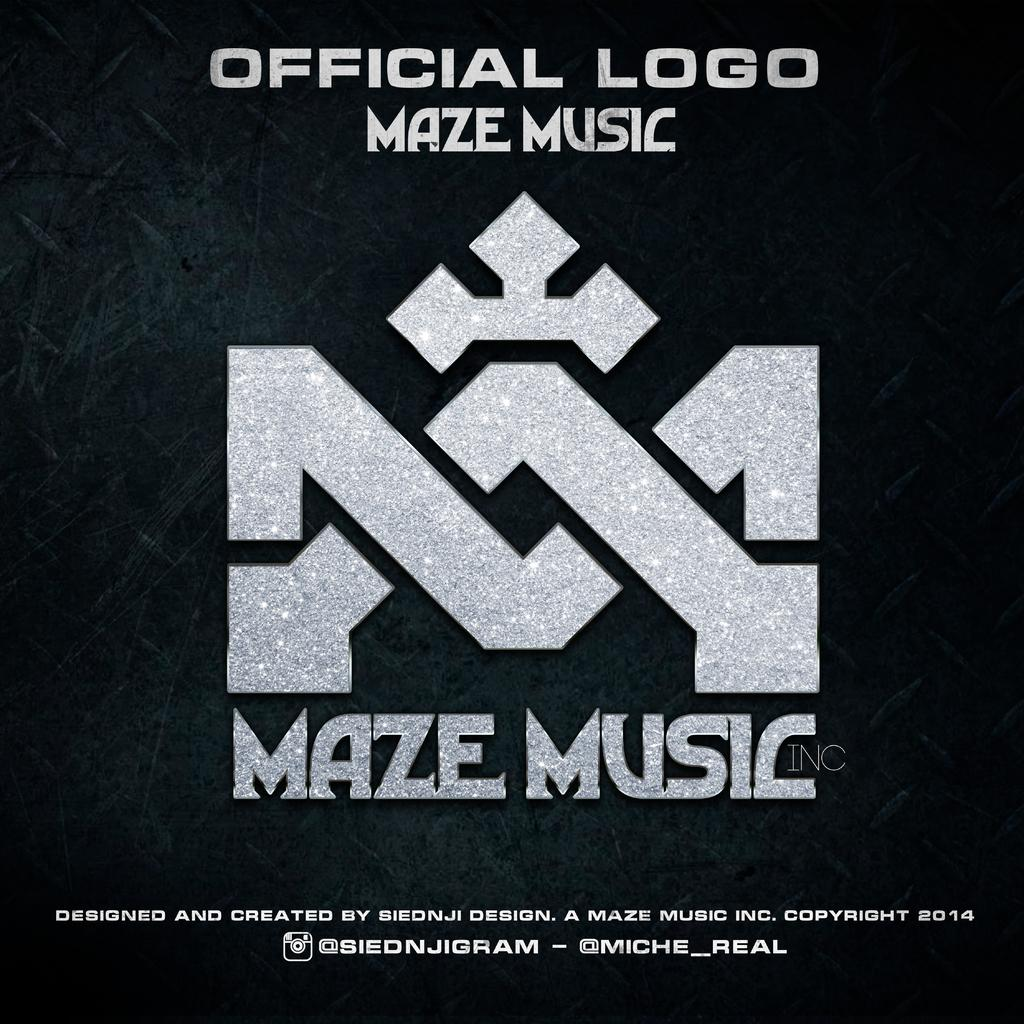What can be found in the image that contains written information? There is text in the image. What type of symbol is present in the image? There is a logo in the image. What color is the background of the image? The background of the image is black. Can you recite the verse that is written in the image? There is no verse present in the image; it contains text and a logo. What is the tax rate mentioned in the image? There is no mention of tax or tax rates in the image. 